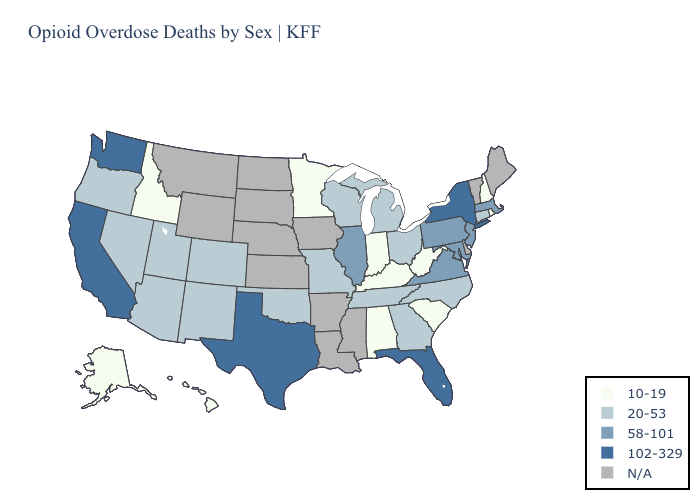What is the highest value in the MidWest ?
Short answer required. 58-101. Does West Virginia have the lowest value in the USA?
Quick response, please. Yes. Name the states that have a value in the range 58-101?
Concise answer only. Illinois, Maryland, Massachusetts, New Jersey, Pennsylvania, Virginia. Which states have the highest value in the USA?
Quick response, please. California, Florida, New York, Texas, Washington. Does the first symbol in the legend represent the smallest category?
Short answer required. Yes. Which states have the lowest value in the USA?
Be succinct. Alabama, Alaska, Hawaii, Idaho, Indiana, Kentucky, Minnesota, New Hampshire, Rhode Island, South Carolina, West Virginia. Which states have the lowest value in the USA?
Short answer required. Alabama, Alaska, Hawaii, Idaho, Indiana, Kentucky, Minnesota, New Hampshire, Rhode Island, South Carolina, West Virginia. Name the states that have a value in the range 58-101?
Answer briefly. Illinois, Maryland, Massachusetts, New Jersey, Pennsylvania, Virginia. What is the lowest value in the Northeast?
Keep it brief. 10-19. Does the first symbol in the legend represent the smallest category?
Keep it brief. Yes. Which states hav the highest value in the Northeast?
Keep it brief. New York. What is the lowest value in the USA?
Answer briefly. 10-19. What is the value of Mississippi?
Give a very brief answer. N/A. What is the lowest value in the West?
Short answer required. 10-19. 